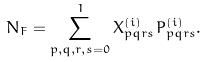<formula> <loc_0><loc_0><loc_500><loc_500>N _ { F } = \sum _ { p , q , r , s = 0 } ^ { 1 } X ^ { ( i ) } _ { p q r s } P _ { p q r s } ^ { ( i ) } .</formula> 